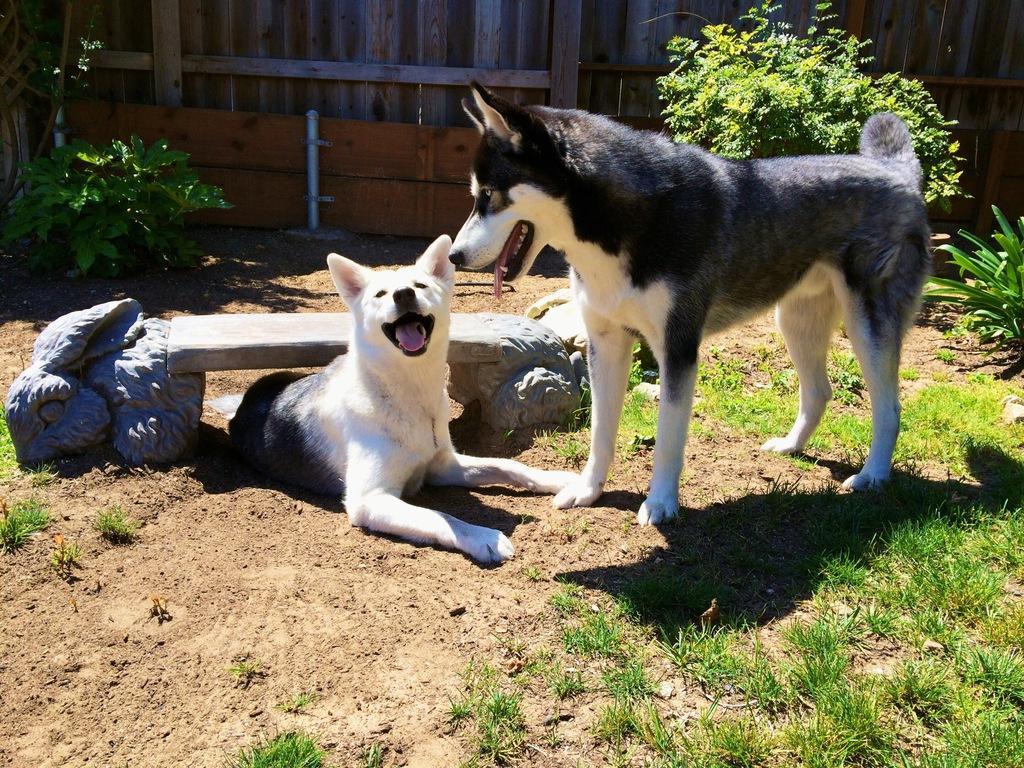Describe this image in one or two sentences. In the foreground of the picture we can see bench, dogs, soil, grass and a plant. In the background we can see trees and wooden railing. 